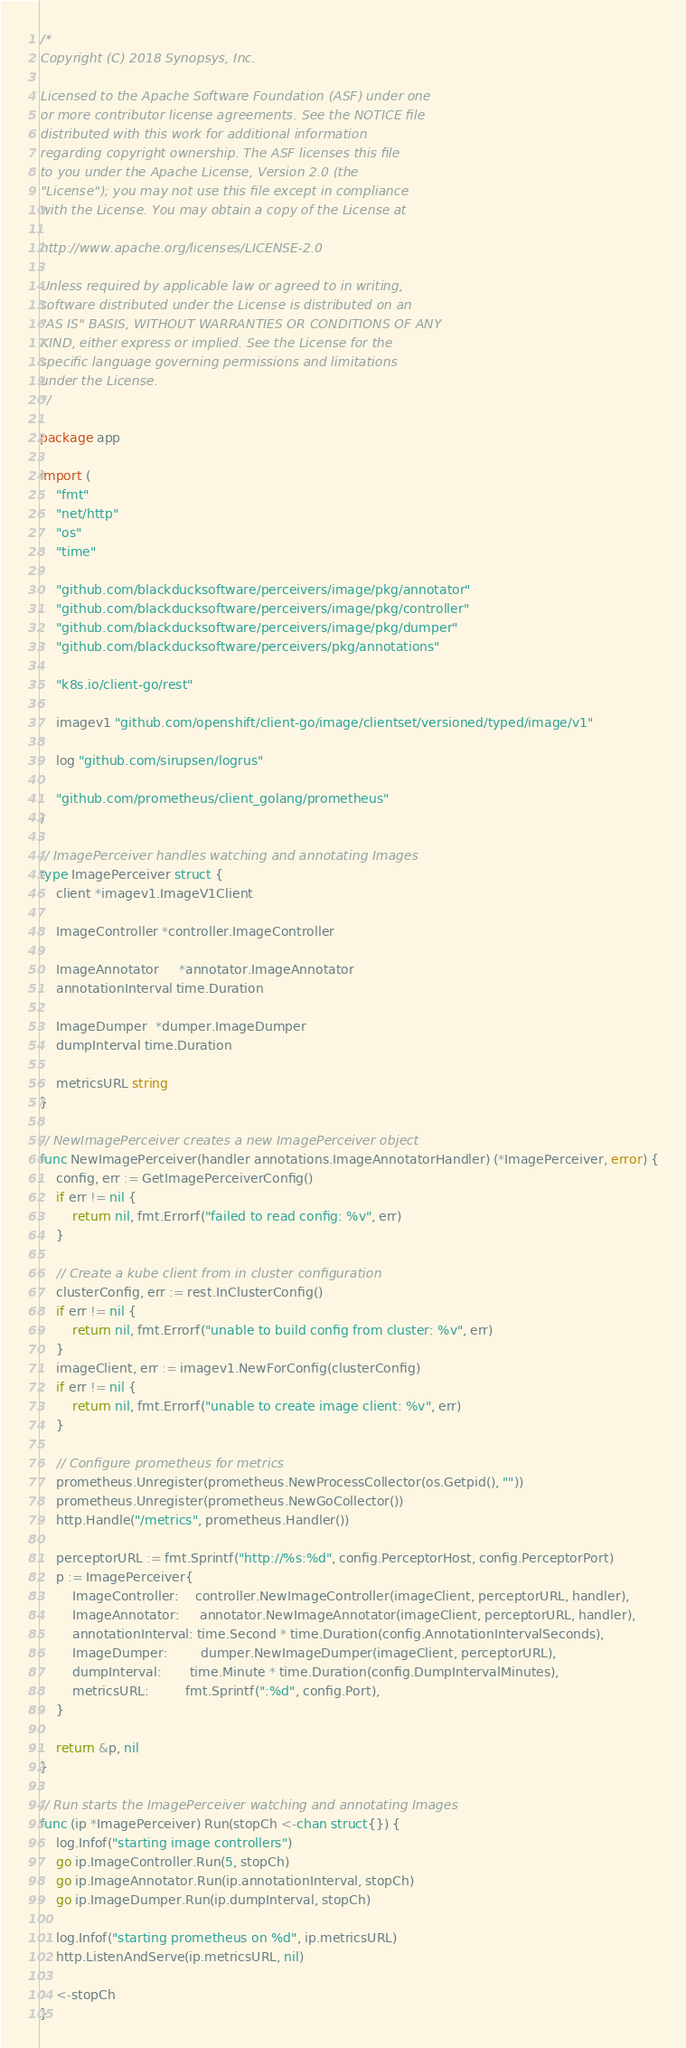<code> <loc_0><loc_0><loc_500><loc_500><_Go_>/*
Copyright (C) 2018 Synopsys, Inc.

Licensed to the Apache Software Foundation (ASF) under one
or more contributor license agreements. See the NOTICE file
distributed with this work for additional information
regarding copyright ownership. The ASF licenses this file
to you under the Apache License, Version 2.0 (the
"License"); you may not use this file except in compliance
with the License. You may obtain a copy of the License at

http://www.apache.org/licenses/LICENSE-2.0

Unless required by applicable law or agreed to in writing,
software distributed under the License is distributed on an
"AS IS" BASIS, WITHOUT WARRANTIES OR CONDITIONS OF ANY
KIND, either express or implied. See the License for the
specific language governing permissions and limitations
under the License.
*/

package app

import (
	"fmt"
	"net/http"
	"os"
	"time"

	"github.com/blackducksoftware/perceivers/image/pkg/annotator"
	"github.com/blackducksoftware/perceivers/image/pkg/controller"
	"github.com/blackducksoftware/perceivers/image/pkg/dumper"
	"github.com/blackducksoftware/perceivers/pkg/annotations"

	"k8s.io/client-go/rest"

	imagev1 "github.com/openshift/client-go/image/clientset/versioned/typed/image/v1"

	log "github.com/sirupsen/logrus"

	"github.com/prometheus/client_golang/prometheus"
)

// ImagePerceiver handles watching and annotating Images
type ImagePerceiver struct {
	client *imagev1.ImageV1Client

	ImageController *controller.ImageController

	ImageAnnotator     *annotator.ImageAnnotator
	annotationInterval time.Duration

	ImageDumper  *dumper.ImageDumper
	dumpInterval time.Duration

	metricsURL string
}

// NewImagePerceiver creates a new ImagePerceiver object
func NewImagePerceiver(handler annotations.ImageAnnotatorHandler) (*ImagePerceiver, error) {
	config, err := GetImagePerceiverConfig()
	if err != nil {
		return nil, fmt.Errorf("failed to read config: %v", err)
	}

	// Create a kube client from in cluster configuration
	clusterConfig, err := rest.InClusterConfig()
	if err != nil {
		return nil, fmt.Errorf("unable to build config from cluster: %v", err)
	}
	imageClient, err := imagev1.NewForConfig(clusterConfig)
	if err != nil {
		return nil, fmt.Errorf("unable to create image client: %v", err)
	}

	// Configure prometheus for metrics
	prometheus.Unregister(prometheus.NewProcessCollector(os.Getpid(), ""))
	prometheus.Unregister(prometheus.NewGoCollector())
	http.Handle("/metrics", prometheus.Handler())

	perceptorURL := fmt.Sprintf("http://%s:%d", config.PerceptorHost, config.PerceptorPort)
	p := ImagePerceiver{
		ImageController:    controller.NewImageController(imageClient, perceptorURL, handler),
		ImageAnnotator:     annotator.NewImageAnnotator(imageClient, perceptorURL, handler),
		annotationInterval: time.Second * time.Duration(config.AnnotationIntervalSeconds),
		ImageDumper:        dumper.NewImageDumper(imageClient, perceptorURL),
		dumpInterval:       time.Minute * time.Duration(config.DumpIntervalMinutes),
		metricsURL:         fmt.Sprintf(":%d", config.Port),
	}

	return &p, nil
}

// Run starts the ImagePerceiver watching and annotating Images
func (ip *ImagePerceiver) Run(stopCh <-chan struct{}) {
	log.Infof("starting image controllers")
	go ip.ImageController.Run(5, stopCh)
	go ip.ImageAnnotator.Run(ip.annotationInterval, stopCh)
	go ip.ImageDumper.Run(ip.dumpInterval, stopCh)

	log.Infof("starting prometheus on %d", ip.metricsURL)
	http.ListenAndServe(ip.metricsURL, nil)

	<-stopCh
}
</code> 